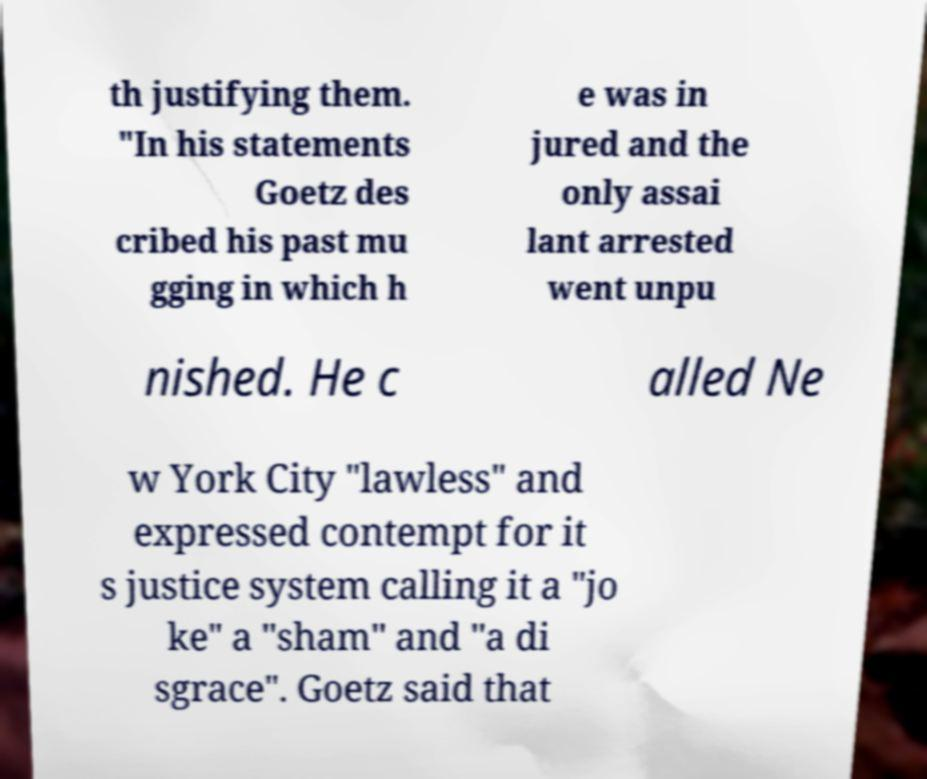Could you extract and type out the text from this image? th justifying them. "In his statements Goetz des cribed his past mu gging in which h e was in jured and the only assai lant arrested went unpu nished. He c alled Ne w York City "lawless" and expressed contempt for it s justice system calling it a "jo ke" a "sham" and "a di sgrace". Goetz said that 